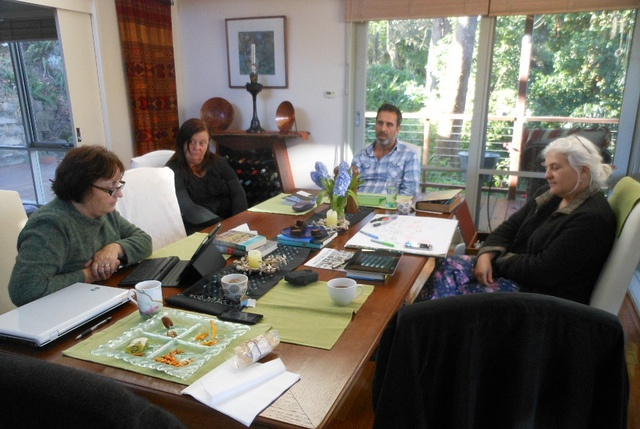Describe the objects in this image and their specific colors. I can see dining table in black, lightgray, darkgray, and tan tones, chair in black and maroon tones, people in black, gray, and darkgray tones, people in black and gray tones, and chair in black and gray tones in this image. 